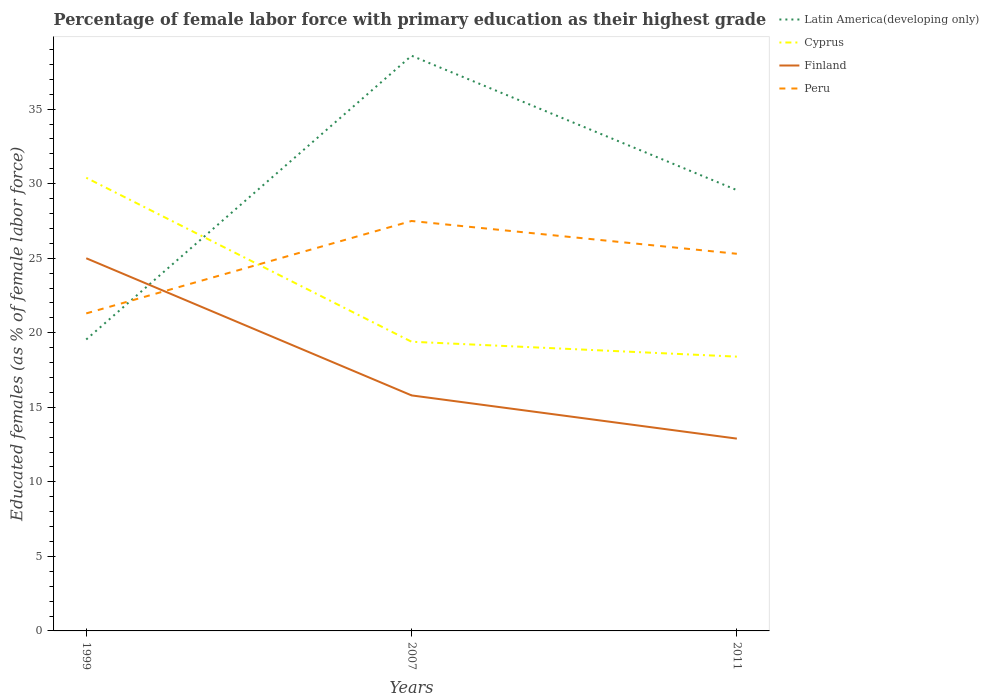How many different coloured lines are there?
Give a very brief answer. 4. Across all years, what is the maximum percentage of female labor force with primary education in Finland?
Give a very brief answer. 12.9. In which year was the percentage of female labor force with primary education in Peru maximum?
Give a very brief answer. 1999. What is the total percentage of female labor force with primary education in Finland in the graph?
Offer a very short reply. 9.2. What is the difference between the highest and the second highest percentage of female labor force with primary education in Finland?
Give a very brief answer. 12.1. Does the graph contain any zero values?
Offer a very short reply. No. How are the legend labels stacked?
Ensure brevity in your answer.  Vertical. What is the title of the graph?
Your response must be concise. Percentage of female labor force with primary education as their highest grade. What is the label or title of the X-axis?
Your answer should be compact. Years. What is the label or title of the Y-axis?
Give a very brief answer. Educated females (as % of female labor force). What is the Educated females (as % of female labor force) in Latin America(developing only) in 1999?
Offer a terse response. 19.55. What is the Educated females (as % of female labor force) in Cyprus in 1999?
Give a very brief answer. 30.4. What is the Educated females (as % of female labor force) in Peru in 1999?
Keep it short and to the point. 21.3. What is the Educated females (as % of female labor force) in Latin America(developing only) in 2007?
Provide a short and direct response. 38.59. What is the Educated females (as % of female labor force) of Cyprus in 2007?
Keep it short and to the point. 19.4. What is the Educated females (as % of female labor force) of Finland in 2007?
Provide a succinct answer. 15.8. What is the Educated females (as % of female labor force) in Peru in 2007?
Provide a short and direct response. 27.5. What is the Educated females (as % of female labor force) in Latin America(developing only) in 2011?
Ensure brevity in your answer.  29.57. What is the Educated females (as % of female labor force) of Cyprus in 2011?
Make the answer very short. 18.4. What is the Educated females (as % of female labor force) of Finland in 2011?
Offer a terse response. 12.9. What is the Educated females (as % of female labor force) of Peru in 2011?
Your response must be concise. 25.3. Across all years, what is the maximum Educated females (as % of female labor force) in Latin America(developing only)?
Make the answer very short. 38.59. Across all years, what is the maximum Educated females (as % of female labor force) in Cyprus?
Offer a very short reply. 30.4. Across all years, what is the maximum Educated females (as % of female labor force) of Finland?
Give a very brief answer. 25. Across all years, what is the minimum Educated females (as % of female labor force) in Latin America(developing only)?
Offer a very short reply. 19.55. Across all years, what is the minimum Educated females (as % of female labor force) in Cyprus?
Provide a succinct answer. 18.4. Across all years, what is the minimum Educated females (as % of female labor force) in Finland?
Provide a short and direct response. 12.9. Across all years, what is the minimum Educated females (as % of female labor force) of Peru?
Make the answer very short. 21.3. What is the total Educated females (as % of female labor force) of Latin America(developing only) in the graph?
Provide a short and direct response. 87.71. What is the total Educated females (as % of female labor force) in Cyprus in the graph?
Offer a very short reply. 68.2. What is the total Educated females (as % of female labor force) of Finland in the graph?
Your answer should be very brief. 53.7. What is the total Educated females (as % of female labor force) in Peru in the graph?
Make the answer very short. 74.1. What is the difference between the Educated females (as % of female labor force) of Latin America(developing only) in 1999 and that in 2007?
Provide a succinct answer. -19.04. What is the difference between the Educated females (as % of female labor force) in Cyprus in 1999 and that in 2007?
Provide a succinct answer. 11. What is the difference between the Educated females (as % of female labor force) in Latin America(developing only) in 1999 and that in 2011?
Provide a short and direct response. -10.02. What is the difference between the Educated females (as % of female labor force) in Cyprus in 1999 and that in 2011?
Offer a terse response. 12. What is the difference between the Educated females (as % of female labor force) in Finland in 1999 and that in 2011?
Offer a terse response. 12.1. What is the difference between the Educated females (as % of female labor force) in Latin America(developing only) in 2007 and that in 2011?
Your answer should be very brief. 9.02. What is the difference between the Educated females (as % of female labor force) in Finland in 2007 and that in 2011?
Your response must be concise. 2.9. What is the difference between the Educated females (as % of female labor force) of Latin America(developing only) in 1999 and the Educated females (as % of female labor force) of Cyprus in 2007?
Ensure brevity in your answer.  0.15. What is the difference between the Educated females (as % of female labor force) of Latin America(developing only) in 1999 and the Educated females (as % of female labor force) of Finland in 2007?
Make the answer very short. 3.75. What is the difference between the Educated females (as % of female labor force) of Latin America(developing only) in 1999 and the Educated females (as % of female labor force) of Peru in 2007?
Your answer should be compact. -7.95. What is the difference between the Educated females (as % of female labor force) in Cyprus in 1999 and the Educated females (as % of female labor force) in Finland in 2007?
Keep it short and to the point. 14.6. What is the difference between the Educated females (as % of female labor force) in Finland in 1999 and the Educated females (as % of female labor force) in Peru in 2007?
Give a very brief answer. -2.5. What is the difference between the Educated females (as % of female labor force) in Latin America(developing only) in 1999 and the Educated females (as % of female labor force) in Cyprus in 2011?
Offer a terse response. 1.15. What is the difference between the Educated females (as % of female labor force) in Latin America(developing only) in 1999 and the Educated females (as % of female labor force) in Finland in 2011?
Offer a terse response. 6.65. What is the difference between the Educated females (as % of female labor force) in Latin America(developing only) in 1999 and the Educated females (as % of female labor force) in Peru in 2011?
Give a very brief answer. -5.75. What is the difference between the Educated females (as % of female labor force) in Cyprus in 1999 and the Educated females (as % of female labor force) in Finland in 2011?
Provide a succinct answer. 17.5. What is the difference between the Educated females (as % of female labor force) of Cyprus in 1999 and the Educated females (as % of female labor force) of Peru in 2011?
Keep it short and to the point. 5.1. What is the difference between the Educated females (as % of female labor force) of Latin America(developing only) in 2007 and the Educated females (as % of female labor force) of Cyprus in 2011?
Provide a succinct answer. 20.19. What is the difference between the Educated females (as % of female labor force) of Latin America(developing only) in 2007 and the Educated females (as % of female labor force) of Finland in 2011?
Provide a short and direct response. 25.69. What is the difference between the Educated females (as % of female labor force) in Latin America(developing only) in 2007 and the Educated females (as % of female labor force) in Peru in 2011?
Your response must be concise. 13.29. What is the difference between the Educated females (as % of female labor force) of Cyprus in 2007 and the Educated females (as % of female labor force) of Finland in 2011?
Provide a succinct answer. 6.5. What is the difference between the Educated females (as % of female labor force) in Finland in 2007 and the Educated females (as % of female labor force) in Peru in 2011?
Your response must be concise. -9.5. What is the average Educated females (as % of female labor force) of Latin America(developing only) per year?
Your answer should be compact. 29.24. What is the average Educated females (as % of female labor force) in Cyprus per year?
Ensure brevity in your answer.  22.73. What is the average Educated females (as % of female labor force) in Peru per year?
Offer a very short reply. 24.7. In the year 1999, what is the difference between the Educated females (as % of female labor force) of Latin America(developing only) and Educated females (as % of female labor force) of Cyprus?
Your answer should be very brief. -10.85. In the year 1999, what is the difference between the Educated females (as % of female labor force) in Latin America(developing only) and Educated females (as % of female labor force) in Finland?
Make the answer very short. -5.45. In the year 1999, what is the difference between the Educated females (as % of female labor force) in Latin America(developing only) and Educated females (as % of female labor force) in Peru?
Give a very brief answer. -1.75. In the year 1999, what is the difference between the Educated females (as % of female labor force) in Cyprus and Educated females (as % of female labor force) in Finland?
Provide a succinct answer. 5.4. In the year 2007, what is the difference between the Educated females (as % of female labor force) of Latin America(developing only) and Educated females (as % of female labor force) of Cyprus?
Offer a very short reply. 19.19. In the year 2007, what is the difference between the Educated females (as % of female labor force) of Latin America(developing only) and Educated females (as % of female labor force) of Finland?
Keep it short and to the point. 22.79. In the year 2007, what is the difference between the Educated females (as % of female labor force) in Latin America(developing only) and Educated females (as % of female labor force) in Peru?
Give a very brief answer. 11.09. In the year 2007, what is the difference between the Educated females (as % of female labor force) of Cyprus and Educated females (as % of female labor force) of Finland?
Your answer should be compact. 3.6. In the year 2007, what is the difference between the Educated females (as % of female labor force) of Cyprus and Educated females (as % of female labor force) of Peru?
Provide a short and direct response. -8.1. In the year 2007, what is the difference between the Educated females (as % of female labor force) of Finland and Educated females (as % of female labor force) of Peru?
Give a very brief answer. -11.7. In the year 2011, what is the difference between the Educated females (as % of female labor force) of Latin America(developing only) and Educated females (as % of female labor force) of Cyprus?
Your answer should be compact. 11.17. In the year 2011, what is the difference between the Educated females (as % of female labor force) in Latin America(developing only) and Educated females (as % of female labor force) in Finland?
Provide a short and direct response. 16.67. In the year 2011, what is the difference between the Educated females (as % of female labor force) in Latin America(developing only) and Educated females (as % of female labor force) in Peru?
Your answer should be very brief. 4.27. In the year 2011, what is the difference between the Educated females (as % of female labor force) in Cyprus and Educated females (as % of female labor force) in Finland?
Ensure brevity in your answer.  5.5. In the year 2011, what is the difference between the Educated females (as % of female labor force) in Cyprus and Educated females (as % of female labor force) in Peru?
Offer a terse response. -6.9. What is the ratio of the Educated females (as % of female labor force) of Latin America(developing only) in 1999 to that in 2007?
Your answer should be very brief. 0.51. What is the ratio of the Educated females (as % of female labor force) in Cyprus in 1999 to that in 2007?
Offer a terse response. 1.57. What is the ratio of the Educated females (as % of female labor force) of Finland in 1999 to that in 2007?
Ensure brevity in your answer.  1.58. What is the ratio of the Educated females (as % of female labor force) of Peru in 1999 to that in 2007?
Give a very brief answer. 0.77. What is the ratio of the Educated females (as % of female labor force) in Latin America(developing only) in 1999 to that in 2011?
Offer a very short reply. 0.66. What is the ratio of the Educated females (as % of female labor force) in Cyprus in 1999 to that in 2011?
Offer a very short reply. 1.65. What is the ratio of the Educated females (as % of female labor force) in Finland in 1999 to that in 2011?
Your answer should be very brief. 1.94. What is the ratio of the Educated females (as % of female labor force) of Peru in 1999 to that in 2011?
Keep it short and to the point. 0.84. What is the ratio of the Educated females (as % of female labor force) in Latin America(developing only) in 2007 to that in 2011?
Provide a succinct answer. 1.3. What is the ratio of the Educated females (as % of female labor force) of Cyprus in 2007 to that in 2011?
Ensure brevity in your answer.  1.05. What is the ratio of the Educated females (as % of female labor force) in Finland in 2007 to that in 2011?
Give a very brief answer. 1.22. What is the ratio of the Educated females (as % of female labor force) of Peru in 2007 to that in 2011?
Your answer should be compact. 1.09. What is the difference between the highest and the second highest Educated females (as % of female labor force) of Latin America(developing only)?
Keep it short and to the point. 9.02. What is the difference between the highest and the second highest Educated females (as % of female labor force) in Peru?
Make the answer very short. 2.2. What is the difference between the highest and the lowest Educated females (as % of female labor force) of Latin America(developing only)?
Offer a terse response. 19.04. What is the difference between the highest and the lowest Educated females (as % of female labor force) of Cyprus?
Keep it short and to the point. 12. What is the difference between the highest and the lowest Educated females (as % of female labor force) of Finland?
Provide a short and direct response. 12.1. 